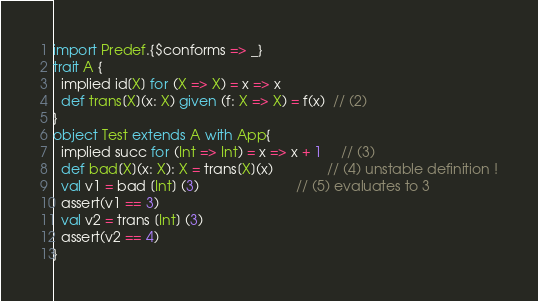Convert code to text. <code><loc_0><loc_0><loc_500><loc_500><_Scala_>
import Predef.{$conforms => _}
trait A {
  implied id[X] for (X => X) = x => x
  def trans[X](x: X) given (f: X => X) = f(x)  // (2)
}
object Test extends A with App{
  implied succ for (Int => Int) = x => x + 1     // (3)
  def bad[X](x: X): X = trans[X](x)              // (4) unstable definition !
  val v1 = bad [Int] (3)                         // (5) evaluates to 3
  assert(v1 == 3)
  val v2 = trans [Int] (3)
  assert(v2 == 4)
}</code> 